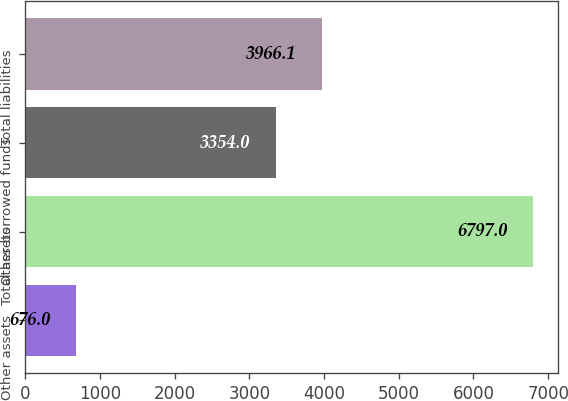Convert chart to OTSL. <chart><loc_0><loc_0><loc_500><loc_500><bar_chart><fcel>Other assets<fcel>Total assets<fcel>Other borrowed funds<fcel>Total liabilities<nl><fcel>676<fcel>6797<fcel>3354<fcel>3966.1<nl></chart> 